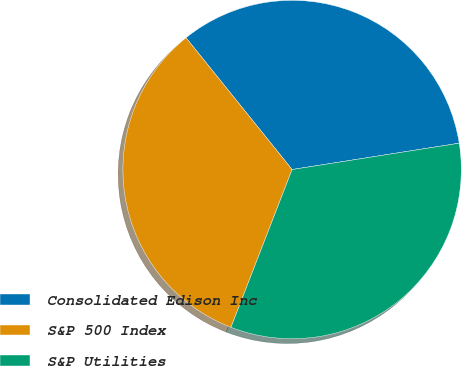<chart> <loc_0><loc_0><loc_500><loc_500><pie_chart><fcel>Consolidated Edison Inc<fcel>S&P 500 Index<fcel>S&P Utilities<nl><fcel>33.3%<fcel>33.33%<fcel>33.37%<nl></chart> 